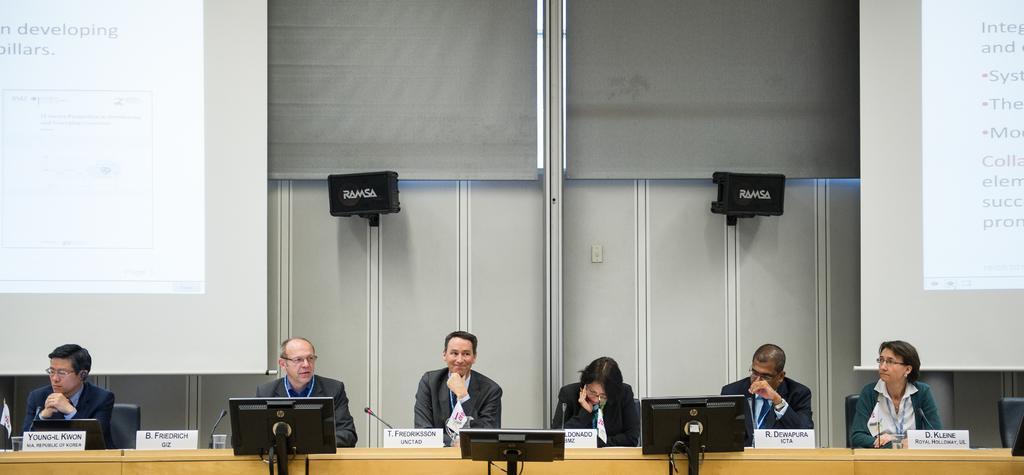Could you give a brief overview of what you see in this image? This image is taken indoors. In the background there is a wall. There are two window blinds. There are two objects and there are two screens with a text on them. At the bottom of the image there is a table with a few name boards, laptops, mics, glasses and a few things on it. There are three monitors. A few people are sitting on the chairs. 